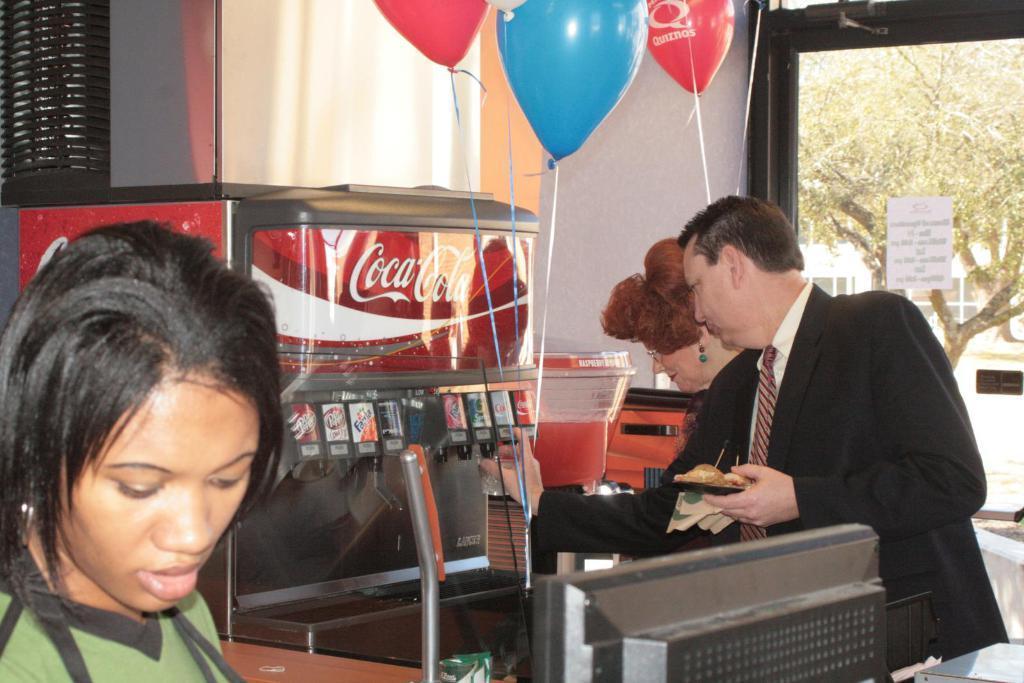Can you describe this image briefly? On the left side of the image there is a person. Behind her there is a table. On top of it there are some objects. There is a person holding a food item. Behind him there is another person. In front of them there is a soft drink machine. there are balloons. In the background of the image there is a wall. There is a curtain. There is a poster attached to the glass window. Through the glass window we can see trees and buildings. 